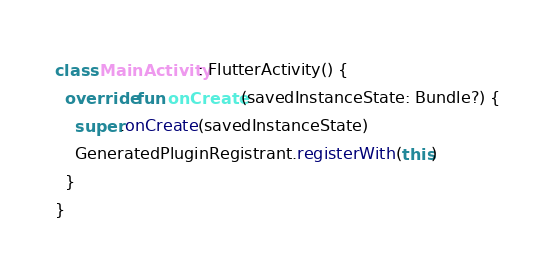<code> <loc_0><loc_0><loc_500><loc_500><_Kotlin_>class MainActivity: FlutterActivity() {
  override fun onCreate(savedInstanceState: Bundle?) {
    super.onCreate(savedInstanceState)
    GeneratedPluginRegistrant.registerWith(this)
  }
}
</code> 